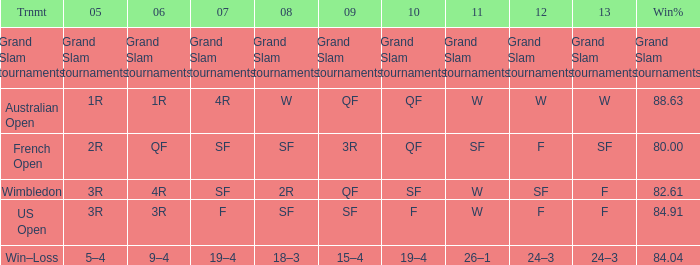When in 2008 that has a 2007 of f? SF. 